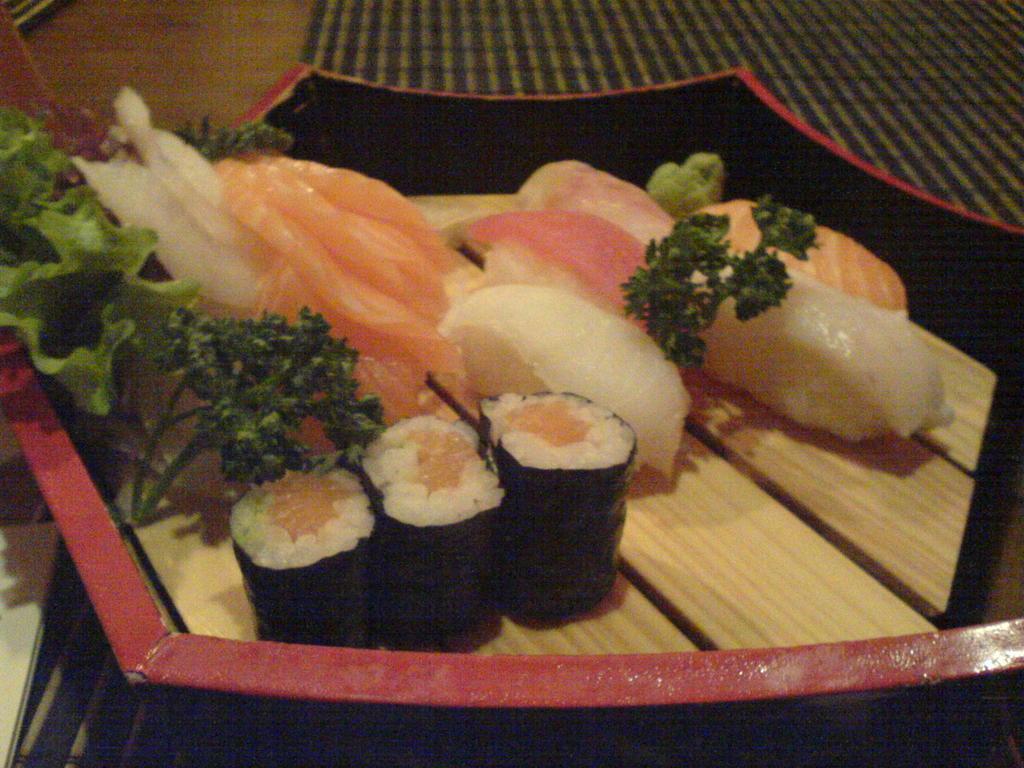Describe this image in one or two sentences. In this picture, there is a bowl placed on the table. In the bowl, there is some food like green leaves, meat, rice etc. 